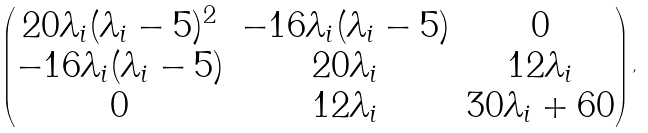Convert formula to latex. <formula><loc_0><loc_0><loc_500><loc_500>\begin{pmatrix} 2 0 \lambda _ { i } ( \lambda _ { i } - 5 ) ^ { 2 } & - 1 6 \lambda _ { i } ( \lambda _ { i } - 5 ) & 0 \\ - 1 6 \lambda _ { i } ( \lambda _ { i } - 5 ) & 2 0 \lambda _ { i } & 1 2 \lambda _ { i } \\ 0 & 1 2 \lambda _ { i } & 3 0 \lambda _ { i } + 6 0 \end{pmatrix} ,</formula> 